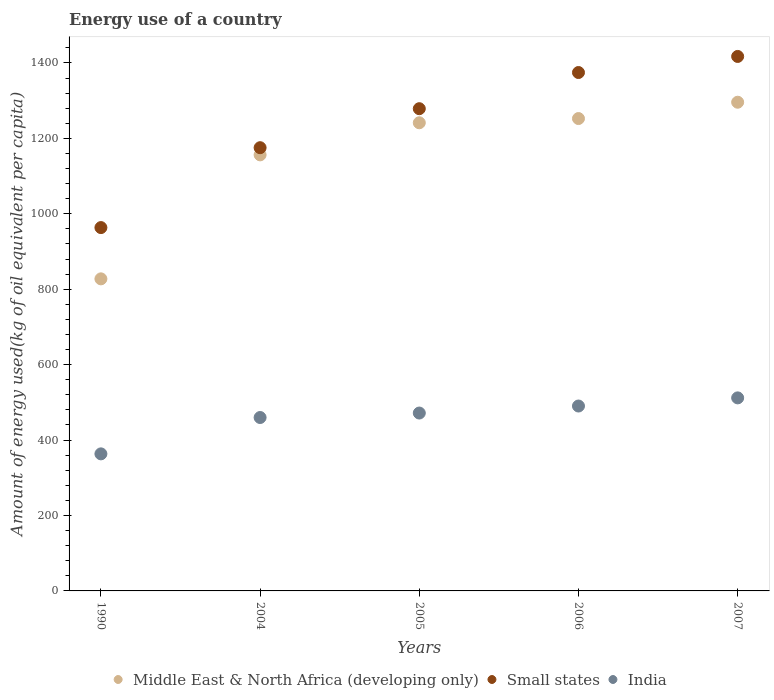Is the number of dotlines equal to the number of legend labels?
Keep it short and to the point. Yes. What is the amount of energy used in in India in 2005?
Provide a succinct answer. 471.66. Across all years, what is the maximum amount of energy used in in Middle East & North Africa (developing only)?
Your answer should be very brief. 1295.81. Across all years, what is the minimum amount of energy used in in Middle East & North Africa (developing only)?
Your answer should be very brief. 827.47. In which year was the amount of energy used in in Small states minimum?
Your answer should be compact. 1990. What is the total amount of energy used in in Middle East & North Africa (developing only) in the graph?
Your response must be concise. 5773.37. What is the difference between the amount of energy used in in India in 1990 and that in 2007?
Your answer should be very brief. -148.44. What is the difference between the amount of energy used in in India in 2005 and the amount of energy used in in Small states in 2007?
Offer a very short reply. -945.53. What is the average amount of energy used in in Small states per year?
Ensure brevity in your answer.  1241.81. In the year 2007, what is the difference between the amount of energy used in in Small states and amount of energy used in in India?
Provide a succinct answer. 905.33. In how many years, is the amount of energy used in in Middle East & North Africa (developing only) greater than 720 kg?
Ensure brevity in your answer.  5. What is the ratio of the amount of energy used in in India in 2004 to that in 2005?
Make the answer very short. 0.97. Is the amount of energy used in in Middle East & North Africa (developing only) in 1990 less than that in 2006?
Your answer should be very brief. Yes. Is the difference between the amount of energy used in in Small states in 2005 and 2006 greater than the difference between the amount of energy used in in India in 2005 and 2006?
Your answer should be very brief. No. What is the difference between the highest and the second highest amount of energy used in in Small states?
Provide a short and direct response. 42.63. What is the difference between the highest and the lowest amount of energy used in in Middle East & North Africa (developing only)?
Your response must be concise. 468.34. Is the amount of energy used in in Small states strictly greater than the amount of energy used in in Middle East & North Africa (developing only) over the years?
Ensure brevity in your answer.  Yes. Are the values on the major ticks of Y-axis written in scientific E-notation?
Your answer should be compact. No. Does the graph contain grids?
Make the answer very short. No. How many legend labels are there?
Make the answer very short. 3. What is the title of the graph?
Give a very brief answer. Energy use of a country. What is the label or title of the Y-axis?
Your response must be concise. Amount of energy used(kg of oil equivalent per capita). What is the Amount of energy used(kg of oil equivalent per capita) in Middle East & North Africa (developing only) in 1990?
Provide a short and direct response. 827.47. What is the Amount of energy used(kg of oil equivalent per capita) in Small states in 1990?
Offer a very short reply. 963.4. What is the Amount of energy used(kg of oil equivalent per capita) in India in 1990?
Give a very brief answer. 363.43. What is the Amount of energy used(kg of oil equivalent per capita) of Middle East & North Africa (developing only) in 2004?
Provide a short and direct response. 1156.23. What is the Amount of energy used(kg of oil equivalent per capita) of Small states in 2004?
Offer a very short reply. 1175.26. What is the Amount of energy used(kg of oil equivalent per capita) of India in 2004?
Offer a very short reply. 459.81. What is the Amount of energy used(kg of oil equivalent per capita) of Middle East & North Africa (developing only) in 2005?
Make the answer very short. 1241.33. What is the Amount of energy used(kg of oil equivalent per capita) of Small states in 2005?
Provide a short and direct response. 1278.65. What is the Amount of energy used(kg of oil equivalent per capita) in India in 2005?
Make the answer very short. 471.66. What is the Amount of energy used(kg of oil equivalent per capita) in Middle East & North Africa (developing only) in 2006?
Ensure brevity in your answer.  1252.52. What is the Amount of energy used(kg of oil equivalent per capita) in Small states in 2006?
Provide a short and direct response. 1374.57. What is the Amount of energy used(kg of oil equivalent per capita) in India in 2006?
Offer a very short reply. 490.27. What is the Amount of energy used(kg of oil equivalent per capita) of Middle East & North Africa (developing only) in 2007?
Your answer should be very brief. 1295.81. What is the Amount of energy used(kg of oil equivalent per capita) of Small states in 2007?
Your response must be concise. 1417.19. What is the Amount of energy used(kg of oil equivalent per capita) in India in 2007?
Ensure brevity in your answer.  511.87. Across all years, what is the maximum Amount of energy used(kg of oil equivalent per capita) in Middle East & North Africa (developing only)?
Provide a succinct answer. 1295.81. Across all years, what is the maximum Amount of energy used(kg of oil equivalent per capita) in Small states?
Provide a succinct answer. 1417.19. Across all years, what is the maximum Amount of energy used(kg of oil equivalent per capita) of India?
Your answer should be compact. 511.87. Across all years, what is the minimum Amount of energy used(kg of oil equivalent per capita) in Middle East & North Africa (developing only)?
Offer a terse response. 827.47. Across all years, what is the minimum Amount of energy used(kg of oil equivalent per capita) of Small states?
Provide a succinct answer. 963.4. Across all years, what is the minimum Amount of energy used(kg of oil equivalent per capita) in India?
Keep it short and to the point. 363.43. What is the total Amount of energy used(kg of oil equivalent per capita) in Middle East & North Africa (developing only) in the graph?
Your answer should be compact. 5773.37. What is the total Amount of energy used(kg of oil equivalent per capita) in Small states in the graph?
Give a very brief answer. 6209.07. What is the total Amount of energy used(kg of oil equivalent per capita) of India in the graph?
Give a very brief answer. 2297.03. What is the difference between the Amount of energy used(kg of oil equivalent per capita) in Middle East & North Africa (developing only) in 1990 and that in 2004?
Give a very brief answer. -328.76. What is the difference between the Amount of energy used(kg of oil equivalent per capita) in Small states in 1990 and that in 2004?
Make the answer very short. -211.86. What is the difference between the Amount of energy used(kg of oil equivalent per capita) in India in 1990 and that in 2004?
Provide a succinct answer. -96.38. What is the difference between the Amount of energy used(kg of oil equivalent per capita) in Middle East & North Africa (developing only) in 1990 and that in 2005?
Provide a short and direct response. -413.86. What is the difference between the Amount of energy used(kg of oil equivalent per capita) in Small states in 1990 and that in 2005?
Your answer should be compact. -315.26. What is the difference between the Amount of energy used(kg of oil equivalent per capita) of India in 1990 and that in 2005?
Offer a terse response. -108.24. What is the difference between the Amount of energy used(kg of oil equivalent per capita) of Middle East & North Africa (developing only) in 1990 and that in 2006?
Offer a terse response. -425.05. What is the difference between the Amount of energy used(kg of oil equivalent per capita) of Small states in 1990 and that in 2006?
Offer a very short reply. -411.17. What is the difference between the Amount of energy used(kg of oil equivalent per capita) in India in 1990 and that in 2006?
Keep it short and to the point. -126.84. What is the difference between the Amount of energy used(kg of oil equivalent per capita) of Middle East & North Africa (developing only) in 1990 and that in 2007?
Offer a very short reply. -468.34. What is the difference between the Amount of energy used(kg of oil equivalent per capita) in Small states in 1990 and that in 2007?
Offer a terse response. -453.8. What is the difference between the Amount of energy used(kg of oil equivalent per capita) of India in 1990 and that in 2007?
Offer a terse response. -148.44. What is the difference between the Amount of energy used(kg of oil equivalent per capita) of Middle East & North Africa (developing only) in 2004 and that in 2005?
Your answer should be very brief. -85.1. What is the difference between the Amount of energy used(kg of oil equivalent per capita) in Small states in 2004 and that in 2005?
Your response must be concise. -103.39. What is the difference between the Amount of energy used(kg of oil equivalent per capita) in India in 2004 and that in 2005?
Provide a succinct answer. -11.86. What is the difference between the Amount of energy used(kg of oil equivalent per capita) of Middle East & North Africa (developing only) in 2004 and that in 2006?
Ensure brevity in your answer.  -96.29. What is the difference between the Amount of energy used(kg of oil equivalent per capita) of Small states in 2004 and that in 2006?
Your response must be concise. -199.31. What is the difference between the Amount of energy used(kg of oil equivalent per capita) in India in 2004 and that in 2006?
Offer a terse response. -30.46. What is the difference between the Amount of energy used(kg of oil equivalent per capita) in Middle East & North Africa (developing only) in 2004 and that in 2007?
Provide a short and direct response. -139.58. What is the difference between the Amount of energy used(kg of oil equivalent per capita) in Small states in 2004 and that in 2007?
Keep it short and to the point. -241.94. What is the difference between the Amount of energy used(kg of oil equivalent per capita) of India in 2004 and that in 2007?
Provide a succinct answer. -52.06. What is the difference between the Amount of energy used(kg of oil equivalent per capita) of Middle East & North Africa (developing only) in 2005 and that in 2006?
Ensure brevity in your answer.  -11.2. What is the difference between the Amount of energy used(kg of oil equivalent per capita) in Small states in 2005 and that in 2006?
Your response must be concise. -95.91. What is the difference between the Amount of energy used(kg of oil equivalent per capita) of India in 2005 and that in 2006?
Your answer should be very brief. -18.6. What is the difference between the Amount of energy used(kg of oil equivalent per capita) in Middle East & North Africa (developing only) in 2005 and that in 2007?
Provide a short and direct response. -54.49. What is the difference between the Amount of energy used(kg of oil equivalent per capita) in Small states in 2005 and that in 2007?
Your response must be concise. -138.54. What is the difference between the Amount of energy used(kg of oil equivalent per capita) of India in 2005 and that in 2007?
Offer a terse response. -40.2. What is the difference between the Amount of energy used(kg of oil equivalent per capita) in Middle East & North Africa (developing only) in 2006 and that in 2007?
Your answer should be compact. -43.29. What is the difference between the Amount of energy used(kg of oil equivalent per capita) in Small states in 2006 and that in 2007?
Offer a very short reply. -42.63. What is the difference between the Amount of energy used(kg of oil equivalent per capita) of India in 2006 and that in 2007?
Give a very brief answer. -21.6. What is the difference between the Amount of energy used(kg of oil equivalent per capita) of Middle East & North Africa (developing only) in 1990 and the Amount of energy used(kg of oil equivalent per capita) of Small states in 2004?
Ensure brevity in your answer.  -347.79. What is the difference between the Amount of energy used(kg of oil equivalent per capita) in Middle East & North Africa (developing only) in 1990 and the Amount of energy used(kg of oil equivalent per capita) in India in 2004?
Ensure brevity in your answer.  367.66. What is the difference between the Amount of energy used(kg of oil equivalent per capita) of Small states in 1990 and the Amount of energy used(kg of oil equivalent per capita) of India in 2004?
Your answer should be compact. 503.59. What is the difference between the Amount of energy used(kg of oil equivalent per capita) in Middle East & North Africa (developing only) in 1990 and the Amount of energy used(kg of oil equivalent per capita) in Small states in 2005?
Provide a succinct answer. -451.18. What is the difference between the Amount of energy used(kg of oil equivalent per capita) in Middle East & North Africa (developing only) in 1990 and the Amount of energy used(kg of oil equivalent per capita) in India in 2005?
Offer a terse response. 355.81. What is the difference between the Amount of energy used(kg of oil equivalent per capita) in Small states in 1990 and the Amount of energy used(kg of oil equivalent per capita) in India in 2005?
Your answer should be very brief. 491.73. What is the difference between the Amount of energy used(kg of oil equivalent per capita) of Middle East & North Africa (developing only) in 1990 and the Amount of energy used(kg of oil equivalent per capita) of Small states in 2006?
Provide a short and direct response. -547.1. What is the difference between the Amount of energy used(kg of oil equivalent per capita) in Middle East & North Africa (developing only) in 1990 and the Amount of energy used(kg of oil equivalent per capita) in India in 2006?
Your answer should be compact. 337.2. What is the difference between the Amount of energy used(kg of oil equivalent per capita) of Small states in 1990 and the Amount of energy used(kg of oil equivalent per capita) of India in 2006?
Ensure brevity in your answer.  473.13. What is the difference between the Amount of energy used(kg of oil equivalent per capita) in Middle East & North Africa (developing only) in 1990 and the Amount of energy used(kg of oil equivalent per capita) in Small states in 2007?
Provide a succinct answer. -589.72. What is the difference between the Amount of energy used(kg of oil equivalent per capita) in Middle East & North Africa (developing only) in 1990 and the Amount of energy used(kg of oil equivalent per capita) in India in 2007?
Ensure brevity in your answer.  315.6. What is the difference between the Amount of energy used(kg of oil equivalent per capita) of Small states in 1990 and the Amount of energy used(kg of oil equivalent per capita) of India in 2007?
Your answer should be compact. 451.53. What is the difference between the Amount of energy used(kg of oil equivalent per capita) of Middle East & North Africa (developing only) in 2004 and the Amount of energy used(kg of oil equivalent per capita) of Small states in 2005?
Give a very brief answer. -122.42. What is the difference between the Amount of energy used(kg of oil equivalent per capita) of Middle East & North Africa (developing only) in 2004 and the Amount of energy used(kg of oil equivalent per capita) of India in 2005?
Your answer should be compact. 684.57. What is the difference between the Amount of energy used(kg of oil equivalent per capita) of Small states in 2004 and the Amount of energy used(kg of oil equivalent per capita) of India in 2005?
Your response must be concise. 703.59. What is the difference between the Amount of energy used(kg of oil equivalent per capita) in Middle East & North Africa (developing only) in 2004 and the Amount of energy used(kg of oil equivalent per capita) in Small states in 2006?
Give a very brief answer. -218.34. What is the difference between the Amount of energy used(kg of oil equivalent per capita) in Middle East & North Africa (developing only) in 2004 and the Amount of energy used(kg of oil equivalent per capita) in India in 2006?
Make the answer very short. 665.97. What is the difference between the Amount of energy used(kg of oil equivalent per capita) of Small states in 2004 and the Amount of energy used(kg of oil equivalent per capita) of India in 2006?
Offer a terse response. 684.99. What is the difference between the Amount of energy used(kg of oil equivalent per capita) in Middle East & North Africa (developing only) in 2004 and the Amount of energy used(kg of oil equivalent per capita) in Small states in 2007?
Your response must be concise. -260.96. What is the difference between the Amount of energy used(kg of oil equivalent per capita) of Middle East & North Africa (developing only) in 2004 and the Amount of energy used(kg of oil equivalent per capita) of India in 2007?
Provide a short and direct response. 644.36. What is the difference between the Amount of energy used(kg of oil equivalent per capita) in Small states in 2004 and the Amount of energy used(kg of oil equivalent per capita) in India in 2007?
Your answer should be compact. 663.39. What is the difference between the Amount of energy used(kg of oil equivalent per capita) of Middle East & North Africa (developing only) in 2005 and the Amount of energy used(kg of oil equivalent per capita) of Small states in 2006?
Give a very brief answer. -133.24. What is the difference between the Amount of energy used(kg of oil equivalent per capita) in Middle East & North Africa (developing only) in 2005 and the Amount of energy used(kg of oil equivalent per capita) in India in 2006?
Your response must be concise. 751.06. What is the difference between the Amount of energy used(kg of oil equivalent per capita) of Small states in 2005 and the Amount of energy used(kg of oil equivalent per capita) of India in 2006?
Offer a terse response. 788.39. What is the difference between the Amount of energy used(kg of oil equivalent per capita) in Middle East & North Africa (developing only) in 2005 and the Amount of energy used(kg of oil equivalent per capita) in Small states in 2007?
Provide a short and direct response. -175.87. What is the difference between the Amount of energy used(kg of oil equivalent per capita) of Middle East & North Africa (developing only) in 2005 and the Amount of energy used(kg of oil equivalent per capita) of India in 2007?
Your answer should be very brief. 729.46. What is the difference between the Amount of energy used(kg of oil equivalent per capita) of Small states in 2005 and the Amount of energy used(kg of oil equivalent per capita) of India in 2007?
Provide a succinct answer. 766.78. What is the difference between the Amount of energy used(kg of oil equivalent per capita) of Middle East & North Africa (developing only) in 2006 and the Amount of energy used(kg of oil equivalent per capita) of Small states in 2007?
Provide a succinct answer. -164.67. What is the difference between the Amount of energy used(kg of oil equivalent per capita) of Middle East & North Africa (developing only) in 2006 and the Amount of energy used(kg of oil equivalent per capita) of India in 2007?
Your response must be concise. 740.66. What is the difference between the Amount of energy used(kg of oil equivalent per capita) of Small states in 2006 and the Amount of energy used(kg of oil equivalent per capita) of India in 2007?
Provide a succinct answer. 862.7. What is the average Amount of energy used(kg of oil equivalent per capita) in Middle East & North Africa (developing only) per year?
Make the answer very short. 1154.67. What is the average Amount of energy used(kg of oil equivalent per capita) of Small states per year?
Keep it short and to the point. 1241.81. What is the average Amount of energy used(kg of oil equivalent per capita) of India per year?
Give a very brief answer. 459.41. In the year 1990, what is the difference between the Amount of energy used(kg of oil equivalent per capita) in Middle East & North Africa (developing only) and Amount of energy used(kg of oil equivalent per capita) in Small states?
Provide a succinct answer. -135.93. In the year 1990, what is the difference between the Amount of energy used(kg of oil equivalent per capita) in Middle East & North Africa (developing only) and Amount of energy used(kg of oil equivalent per capita) in India?
Offer a very short reply. 464.04. In the year 1990, what is the difference between the Amount of energy used(kg of oil equivalent per capita) in Small states and Amount of energy used(kg of oil equivalent per capita) in India?
Your answer should be compact. 599.97. In the year 2004, what is the difference between the Amount of energy used(kg of oil equivalent per capita) of Middle East & North Africa (developing only) and Amount of energy used(kg of oil equivalent per capita) of Small states?
Give a very brief answer. -19.03. In the year 2004, what is the difference between the Amount of energy used(kg of oil equivalent per capita) in Middle East & North Africa (developing only) and Amount of energy used(kg of oil equivalent per capita) in India?
Your response must be concise. 696.43. In the year 2004, what is the difference between the Amount of energy used(kg of oil equivalent per capita) in Small states and Amount of energy used(kg of oil equivalent per capita) in India?
Your response must be concise. 715.45. In the year 2005, what is the difference between the Amount of energy used(kg of oil equivalent per capita) of Middle East & North Africa (developing only) and Amount of energy used(kg of oil equivalent per capita) of Small states?
Your response must be concise. -37.32. In the year 2005, what is the difference between the Amount of energy used(kg of oil equivalent per capita) in Middle East & North Africa (developing only) and Amount of energy used(kg of oil equivalent per capita) in India?
Your answer should be compact. 769.66. In the year 2005, what is the difference between the Amount of energy used(kg of oil equivalent per capita) in Small states and Amount of energy used(kg of oil equivalent per capita) in India?
Keep it short and to the point. 806.99. In the year 2006, what is the difference between the Amount of energy used(kg of oil equivalent per capita) of Middle East & North Africa (developing only) and Amount of energy used(kg of oil equivalent per capita) of Small states?
Provide a succinct answer. -122.04. In the year 2006, what is the difference between the Amount of energy used(kg of oil equivalent per capita) in Middle East & North Africa (developing only) and Amount of energy used(kg of oil equivalent per capita) in India?
Provide a short and direct response. 762.26. In the year 2006, what is the difference between the Amount of energy used(kg of oil equivalent per capita) in Small states and Amount of energy used(kg of oil equivalent per capita) in India?
Ensure brevity in your answer.  884.3. In the year 2007, what is the difference between the Amount of energy used(kg of oil equivalent per capita) of Middle East & North Africa (developing only) and Amount of energy used(kg of oil equivalent per capita) of Small states?
Your answer should be compact. -121.38. In the year 2007, what is the difference between the Amount of energy used(kg of oil equivalent per capita) of Middle East & North Africa (developing only) and Amount of energy used(kg of oil equivalent per capita) of India?
Your answer should be very brief. 783.95. In the year 2007, what is the difference between the Amount of energy used(kg of oil equivalent per capita) of Small states and Amount of energy used(kg of oil equivalent per capita) of India?
Your answer should be compact. 905.33. What is the ratio of the Amount of energy used(kg of oil equivalent per capita) of Middle East & North Africa (developing only) in 1990 to that in 2004?
Offer a terse response. 0.72. What is the ratio of the Amount of energy used(kg of oil equivalent per capita) in Small states in 1990 to that in 2004?
Your answer should be very brief. 0.82. What is the ratio of the Amount of energy used(kg of oil equivalent per capita) of India in 1990 to that in 2004?
Provide a short and direct response. 0.79. What is the ratio of the Amount of energy used(kg of oil equivalent per capita) of Middle East & North Africa (developing only) in 1990 to that in 2005?
Offer a very short reply. 0.67. What is the ratio of the Amount of energy used(kg of oil equivalent per capita) of Small states in 1990 to that in 2005?
Keep it short and to the point. 0.75. What is the ratio of the Amount of energy used(kg of oil equivalent per capita) of India in 1990 to that in 2005?
Ensure brevity in your answer.  0.77. What is the ratio of the Amount of energy used(kg of oil equivalent per capita) in Middle East & North Africa (developing only) in 1990 to that in 2006?
Your response must be concise. 0.66. What is the ratio of the Amount of energy used(kg of oil equivalent per capita) in Small states in 1990 to that in 2006?
Provide a short and direct response. 0.7. What is the ratio of the Amount of energy used(kg of oil equivalent per capita) of India in 1990 to that in 2006?
Give a very brief answer. 0.74. What is the ratio of the Amount of energy used(kg of oil equivalent per capita) in Middle East & North Africa (developing only) in 1990 to that in 2007?
Offer a terse response. 0.64. What is the ratio of the Amount of energy used(kg of oil equivalent per capita) in Small states in 1990 to that in 2007?
Your answer should be compact. 0.68. What is the ratio of the Amount of energy used(kg of oil equivalent per capita) of India in 1990 to that in 2007?
Ensure brevity in your answer.  0.71. What is the ratio of the Amount of energy used(kg of oil equivalent per capita) of Middle East & North Africa (developing only) in 2004 to that in 2005?
Offer a terse response. 0.93. What is the ratio of the Amount of energy used(kg of oil equivalent per capita) of Small states in 2004 to that in 2005?
Offer a very short reply. 0.92. What is the ratio of the Amount of energy used(kg of oil equivalent per capita) of India in 2004 to that in 2005?
Offer a very short reply. 0.97. What is the ratio of the Amount of energy used(kg of oil equivalent per capita) of Small states in 2004 to that in 2006?
Your answer should be very brief. 0.85. What is the ratio of the Amount of energy used(kg of oil equivalent per capita) of India in 2004 to that in 2006?
Ensure brevity in your answer.  0.94. What is the ratio of the Amount of energy used(kg of oil equivalent per capita) of Middle East & North Africa (developing only) in 2004 to that in 2007?
Provide a short and direct response. 0.89. What is the ratio of the Amount of energy used(kg of oil equivalent per capita) of Small states in 2004 to that in 2007?
Your answer should be very brief. 0.83. What is the ratio of the Amount of energy used(kg of oil equivalent per capita) in India in 2004 to that in 2007?
Give a very brief answer. 0.9. What is the ratio of the Amount of energy used(kg of oil equivalent per capita) of Small states in 2005 to that in 2006?
Offer a very short reply. 0.93. What is the ratio of the Amount of energy used(kg of oil equivalent per capita) in India in 2005 to that in 2006?
Keep it short and to the point. 0.96. What is the ratio of the Amount of energy used(kg of oil equivalent per capita) in Middle East & North Africa (developing only) in 2005 to that in 2007?
Provide a short and direct response. 0.96. What is the ratio of the Amount of energy used(kg of oil equivalent per capita) of Small states in 2005 to that in 2007?
Give a very brief answer. 0.9. What is the ratio of the Amount of energy used(kg of oil equivalent per capita) in India in 2005 to that in 2007?
Offer a very short reply. 0.92. What is the ratio of the Amount of energy used(kg of oil equivalent per capita) of Middle East & North Africa (developing only) in 2006 to that in 2007?
Your answer should be compact. 0.97. What is the ratio of the Amount of energy used(kg of oil equivalent per capita) in Small states in 2006 to that in 2007?
Offer a very short reply. 0.97. What is the ratio of the Amount of energy used(kg of oil equivalent per capita) in India in 2006 to that in 2007?
Keep it short and to the point. 0.96. What is the difference between the highest and the second highest Amount of energy used(kg of oil equivalent per capita) in Middle East & North Africa (developing only)?
Provide a succinct answer. 43.29. What is the difference between the highest and the second highest Amount of energy used(kg of oil equivalent per capita) of Small states?
Your response must be concise. 42.63. What is the difference between the highest and the second highest Amount of energy used(kg of oil equivalent per capita) in India?
Provide a succinct answer. 21.6. What is the difference between the highest and the lowest Amount of energy used(kg of oil equivalent per capita) of Middle East & North Africa (developing only)?
Ensure brevity in your answer.  468.34. What is the difference between the highest and the lowest Amount of energy used(kg of oil equivalent per capita) of Small states?
Your response must be concise. 453.8. What is the difference between the highest and the lowest Amount of energy used(kg of oil equivalent per capita) in India?
Provide a succinct answer. 148.44. 